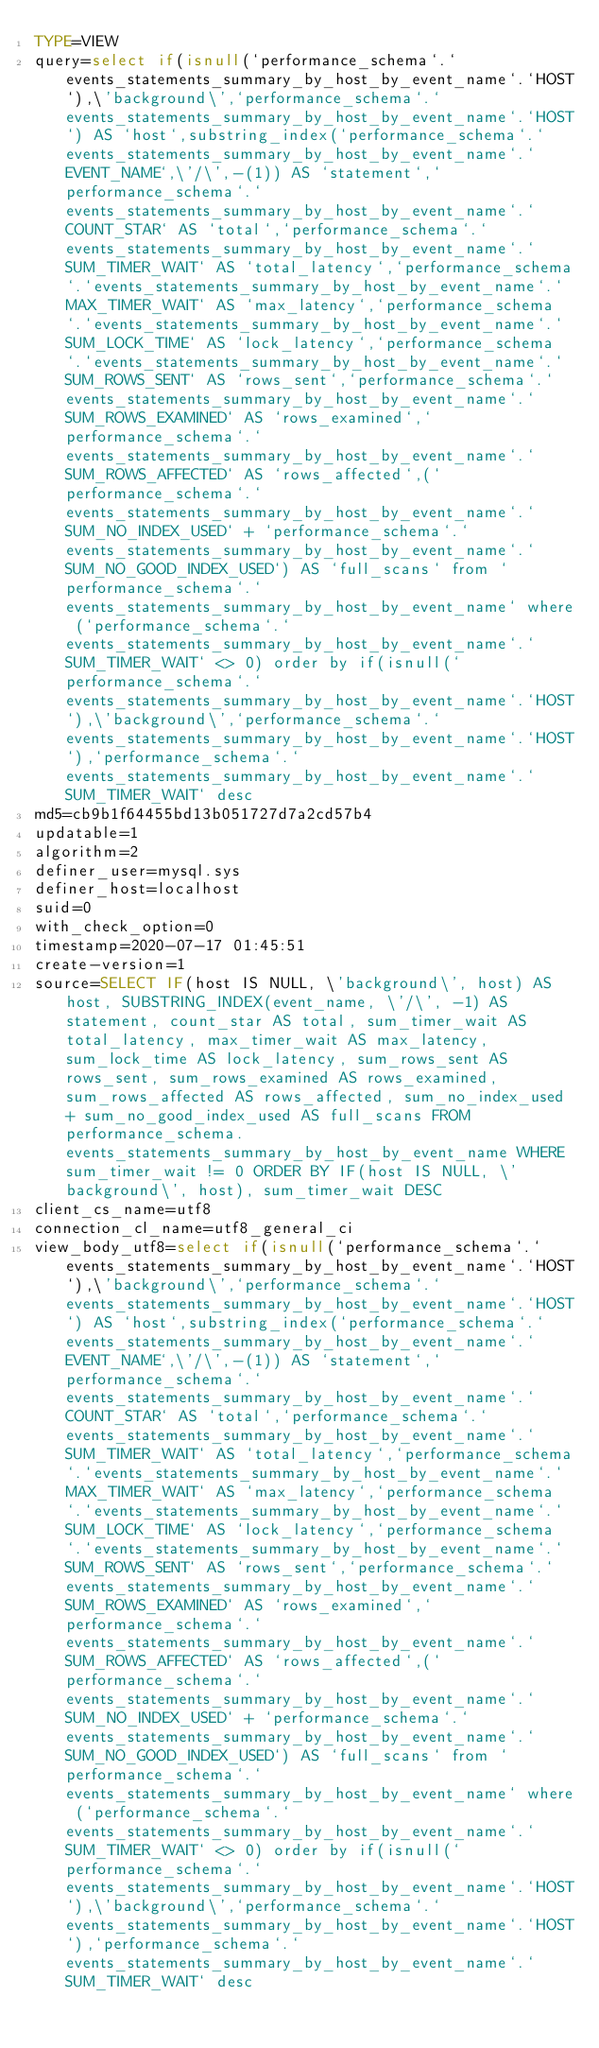Convert code to text. <code><loc_0><loc_0><loc_500><loc_500><_VisualBasic_>TYPE=VIEW
query=select if(isnull(`performance_schema`.`events_statements_summary_by_host_by_event_name`.`HOST`),\'background\',`performance_schema`.`events_statements_summary_by_host_by_event_name`.`HOST`) AS `host`,substring_index(`performance_schema`.`events_statements_summary_by_host_by_event_name`.`EVENT_NAME`,\'/\',-(1)) AS `statement`,`performance_schema`.`events_statements_summary_by_host_by_event_name`.`COUNT_STAR` AS `total`,`performance_schema`.`events_statements_summary_by_host_by_event_name`.`SUM_TIMER_WAIT` AS `total_latency`,`performance_schema`.`events_statements_summary_by_host_by_event_name`.`MAX_TIMER_WAIT` AS `max_latency`,`performance_schema`.`events_statements_summary_by_host_by_event_name`.`SUM_LOCK_TIME` AS `lock_latency`,`performance_schema`.`events_statements_summary_by_host_by_event_name`.`SUM_ROWS_SENT` AS `rows_sent`,`performance_schema`.`events_statements_summary_by_host_by_event_name`.`SUM_ROWS_EXAMINED` AS `rows_examined`,`performance_schema`.`events_statements_summary_by_host_by_event_name`.`SUM_ROWS_AFFECTED` AS `rows_affected`,(`performance_schema`.`events_statements_summary_by_host_by_event_name`.`SUM_NO_INDEX_USED` + `performance_schema`.`events_statements_summary_by_host_by_event_name`.`SUM_NO_GOOD_INDEX_USED`) AS `full_scans` from `performance_schema`.`events_statements_summary_by_host_by_event_name` where (`performance_schema`.`events_statements_summary_by_host_by_event_name`.`SUM_TIMER_WAIT` <> 0) order by if(isnull(`performance_schema`.`events_statements_summary_by_host_by_event_name`.`HOST`),\'background\',`performance_schema`.`events_statements_summary_by_host_by_event_name`.`HOST`),`performance_schema`.`events_statements_summary_by_host_by_event_name`.`SUM_TIMER_WAIT` desc
md5=cb9b1f64455bd13b051727d7a2cd57b4
updatable=1
algorithm=2
definer_user=mysql.sys
definer_host=localhost
suid=0
with_check_option=0
timestamp=2020-07-17 01:45:51
create-version=1
source=SELECT IF(host IS NULL, \'background\', host) AS host, SUBSTRING_INDEX(event_name, \'/\', -1) AS statement, count_star AS total, sum_timer_wait AS total_latency, max_timer_wait AS max_latency, sum_lock_time AS lock_latency, sum_rows_sent AS rows_sent, sum_rows_examined AS rows_examined, sum_rows_affected AS rows_affected, sum_no_index_used + sum_no_good_index_used AS full_scans FROM performance_schema.events_statements_summary_by_host_by_event_name WHERE sum_timer_wait != 0 ORDER BY IF(host IS NULL, \'background\', host), sum_timer_wait DESC
client_cs_name=utf8
connection_cl_name=utf8_general_ci
view_body_utf8=select if(isnull(`performance_schema`.`events_statements_summary_by_host_by_event_name`.`HOST`),\'background\',`performance_schema`.`events_statements_summary_by_host_by_event_name`.`HOST`) AS `host`,substring_index(`performance_schema`.`events_statements_summary_by_host_by_event_name`.`EVENT_NAME`,\'/\',-(1)) AS `statement`,`performance_schema`.`events_statements_summary_by_host_by_event_name`.`COUNT_STAR` AS `total`,`performance_schema`.`events_statements_summary_by_host_by_event_name`.`SUM_TIMER_WAIT` AS `total_latency`,`performance_schema`.`events_statements_summary_by_host_by_event_name`.`MAX_TIMER_WAIT` AS `max_latency`,`performance_schema`.`events_statements_summary_by_host_by_event_name`.`SUM_LOCK_TIME` AS `lock_latency`,`performance_schema`.`events_statements_summary_by_host_by_event_name`.`SUM_ROWS_SENT` AS `rows_sent`,`performance_schema`.`events_statements_summary_by_host_by_event_name`.`SUM_ROWS_EXAMINED` AS `rows_examined`,`performance_schema`.`events_statements_summary_by_host_by_event_name`.`SUM_ROWS_AFFECTED` AS `rows_affected`,(`performance_schema`.`events_statements_summary_by_host_by_event_name`.`SUM_NO_INDEX_USED` + `performance_schema`.`events_statements_summary_by_host_by_event_name`.`SUM_NO_GOOD_INDEX_USED`) AS `full_scans` from `performance_schema`.`events_statements_summary_by_host_by_event_name` where (`performance_schema`.`events_statements_summary_by_host_by_event_name`.`SUM_TIMER_WAIT` <> 0) order by if(isnull(`performance_schema`.`events_statements_summary_by_host_by_event_name`.`HOST`),\'background\',`performance_schema`.`events_statements_summary_by_host_by_event_name`.`HOST`),`performance_schema`.`events_statements_summary_by_host_by_event_name`.`SUM_TIMER_WAIT` desc
</code> 